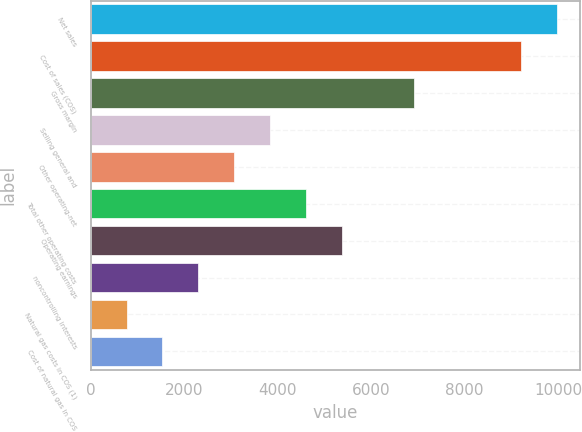Convert chart. <chart><loc_0><loc_0><loc_500><loc_500><bar_chart><fcel>Net sales<fcel>Cost of sales (COS)<fcel>Gross margin<fcel>Selling general and<fcel>Other operating-net<fcel>Total other operating costs<fcel>Operating earnings<fcel>noncontrolling interests<fcel>Natural gas costs in COS (1)<fcel>Cost of natural gas in COS<nl><fcel>9974.13<fcel>9207.09<fcel>6905.97<fcel>3837.81<fcel>3070.77<fcel>4604.85<fcel>5371.89<fcel>2303.73<fcel>769.65<fcel>1536.69<nl></chart> 